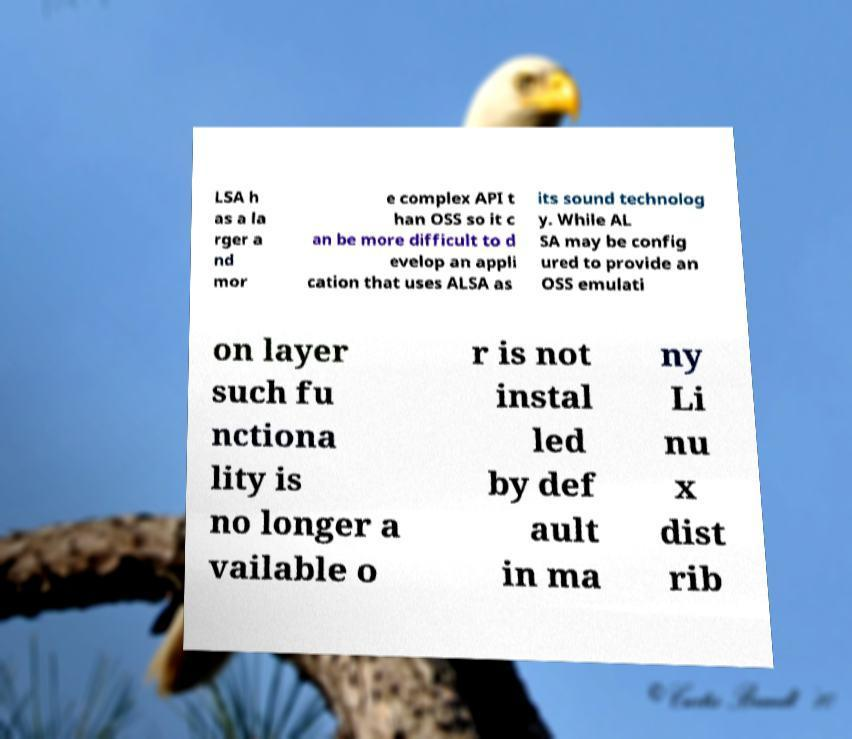There's text embedded in this image that I need extracted. Can you transcribe it verbatim? LSA h as a la rger a nd mor e complex API t han OSS so it c an be more difficult to d evelop an appli cation that uses ALSA as its sound technolog y. While AL SA may be config ured to provide an OSS emulati on layer such fu nctiona lity is no longer a vailable o r is not instal led by def ault in ma ny Li nu x dist rib 